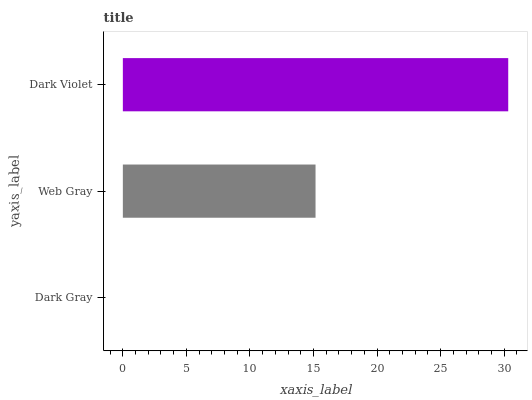Is Dark Gray the minimum?
Answer yes or no. Yes. Is Dark Violet the maximum?
Answer yes or no. Yes. Is Web Gray the minimum?
Answer yes or no. No. Is Web Gray the maximum?
Answer yes or no. No. Is Web Gray greater than Dark Gray?
Answer yes or no. Yes. Is Dark Gray less than Web Gray?
Answer yes or no. Yes. Is Dark Gray greater than Web Gray?
Answer yes or no. No. Is Web Gray less than Dark Gray?
Answer yes or no. No. Is Web Gray the high median?
Answer yes or no. Yes. Is Web Gray the low median?
Answer yes or no. Yes. Is Dark Violet the high median?
Answer yes or no. No. Is Dark Gray the low median?
Answer yes or no. No. 